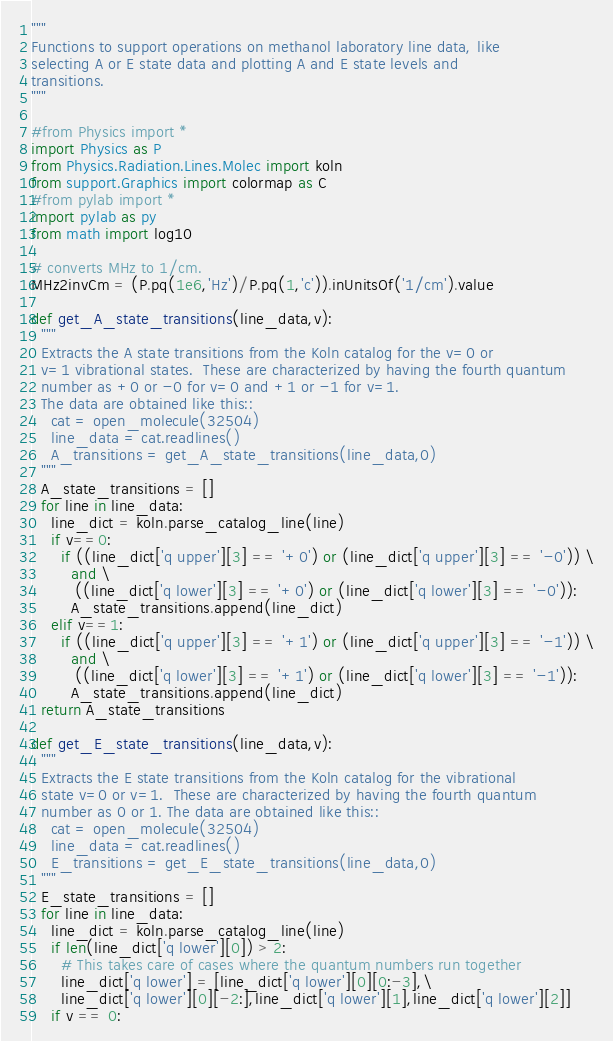Convert code to text. <code><loc_0><loc_0><loc_500><loc_500><_Python_>"""
Functions to support operations on methanol laboratory line data, like
selecting A or E state data and plotting A and E state levels and
transitions.
"""

#from Physics import *
import Physics as P
from Physics.Radiation.Lines.Molec import koln
from support.Graphics import colormap as C
#from pylab import *
import pylab as py
from math import log10

# converts MHz to 1/cm.
MHz2invCm = (P.pq(1e6,'Hz')/P.pq(1,'c')).inUnitsOf('1/cm').value

def get_A_state_transitions(line_data,v):
  """
  Extracts the A state transitions from the Koln catalog for the v=0 or
  v=1 vibrational states.  These are characterized by having the fourth quantum
  number as +0 or -0 for v=0 and +1 or -1 for v=1.
  The data are obtained like this::
    cat = open_molecule(32504)
    line_data = cat.readlines()
    A_transitions = get_A_state_transitions(line_data,0)
  """
  A_state_transitions = []
  for line in line_data:
    line_dict = koln.parse_catalog_line(line)
    if v==0:
      if ((line_dict['q upper'][3] == '+0') or (line_dict['q upper'][3] == '-0')) \
        and \
         ((line_dict['q lower'][3] == '+0') or (line_dict['q lower'][3] == '-0')):
        A_state_transitions.append(line_dict)
    elif v==1:
      if ((line_dict['q upper'][3] == '+1') or (line_dict['q upper'][3] == '-1')) \
        and \
         ((line_dict['q lower'][3] == '+1') or (line_dict['q lower'][3] == '-1')):
        A_state_transitions.append(line_dict)
  return A_state_transitions

def get_E_state_transitions(line_data,v):
  """
  Extracts the E state transitions from the Koln catalog for the vibrational
  state v=0 or v=1.  These are characterized by having the fourth quantum
  number as 0 or 1. The data are obtained like this::
    cat = open_molecule(32504)
    line_data = cat.readlines()
    E_transitions = get_E_state_transitions(line_data,0)
  """
  E_state_transitions = []
  for line in line_data:
    line_dict = koln.parse_catalog_line(line)
    if len(line_dict['q lower'][0]) > 2:
      # This takes care of cases where the quantum numbers run together
      line_dict['q lower'] = [line_dict['q lower'][0][0:-3],\
      line_dict['q lower'][0][-2:],line_dict['q lower'][1],line_dict['q lower'][2]]
    if v == 0:</code> 